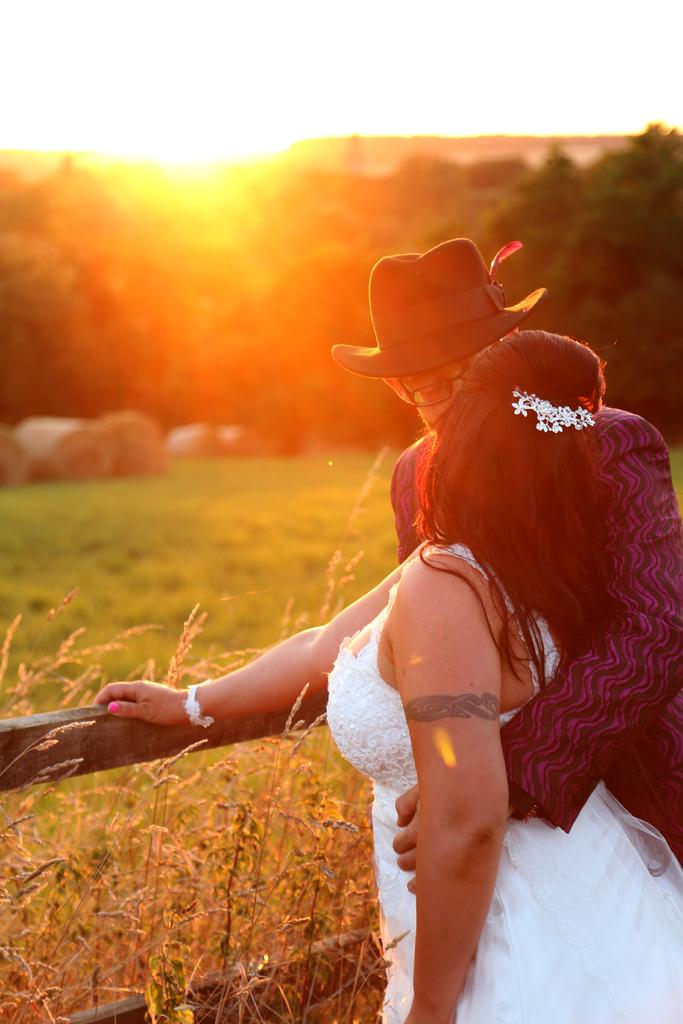What is located in the foreground of the picture? There are plants and a railing in the foreground of the picture. How many people can be seen in the foreground of the picture? Two persons are standing in the foreground of the picture. What is visible in the background of the picture? The background of the image is blurred, but trees, grass, and the sun can be seen. Can you describe the condition of the sky in the image? The sun is visible in the background of the image, indicating that the sky is likely clear or partly cloudy. What type of love can be seen between the two persons in the image? There is no indication of love or any relationship between the two persons in the image; they are simply standing in the foreground. What form does the swing take in the image? There is no swing present in the image. 